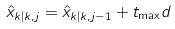<formula> <loc_0><loc_0><loc_500><loc_500>\hat { x } _ { k | k , j } = \hat { x } _ { k | k , j - 1 } + t _ { \max } d</formula> 